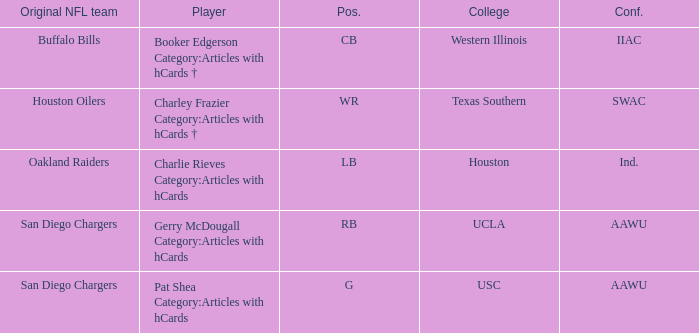Who started their career with the buffalo bills as their original team? Booker Edgerson Category:Articles with hCards †. 